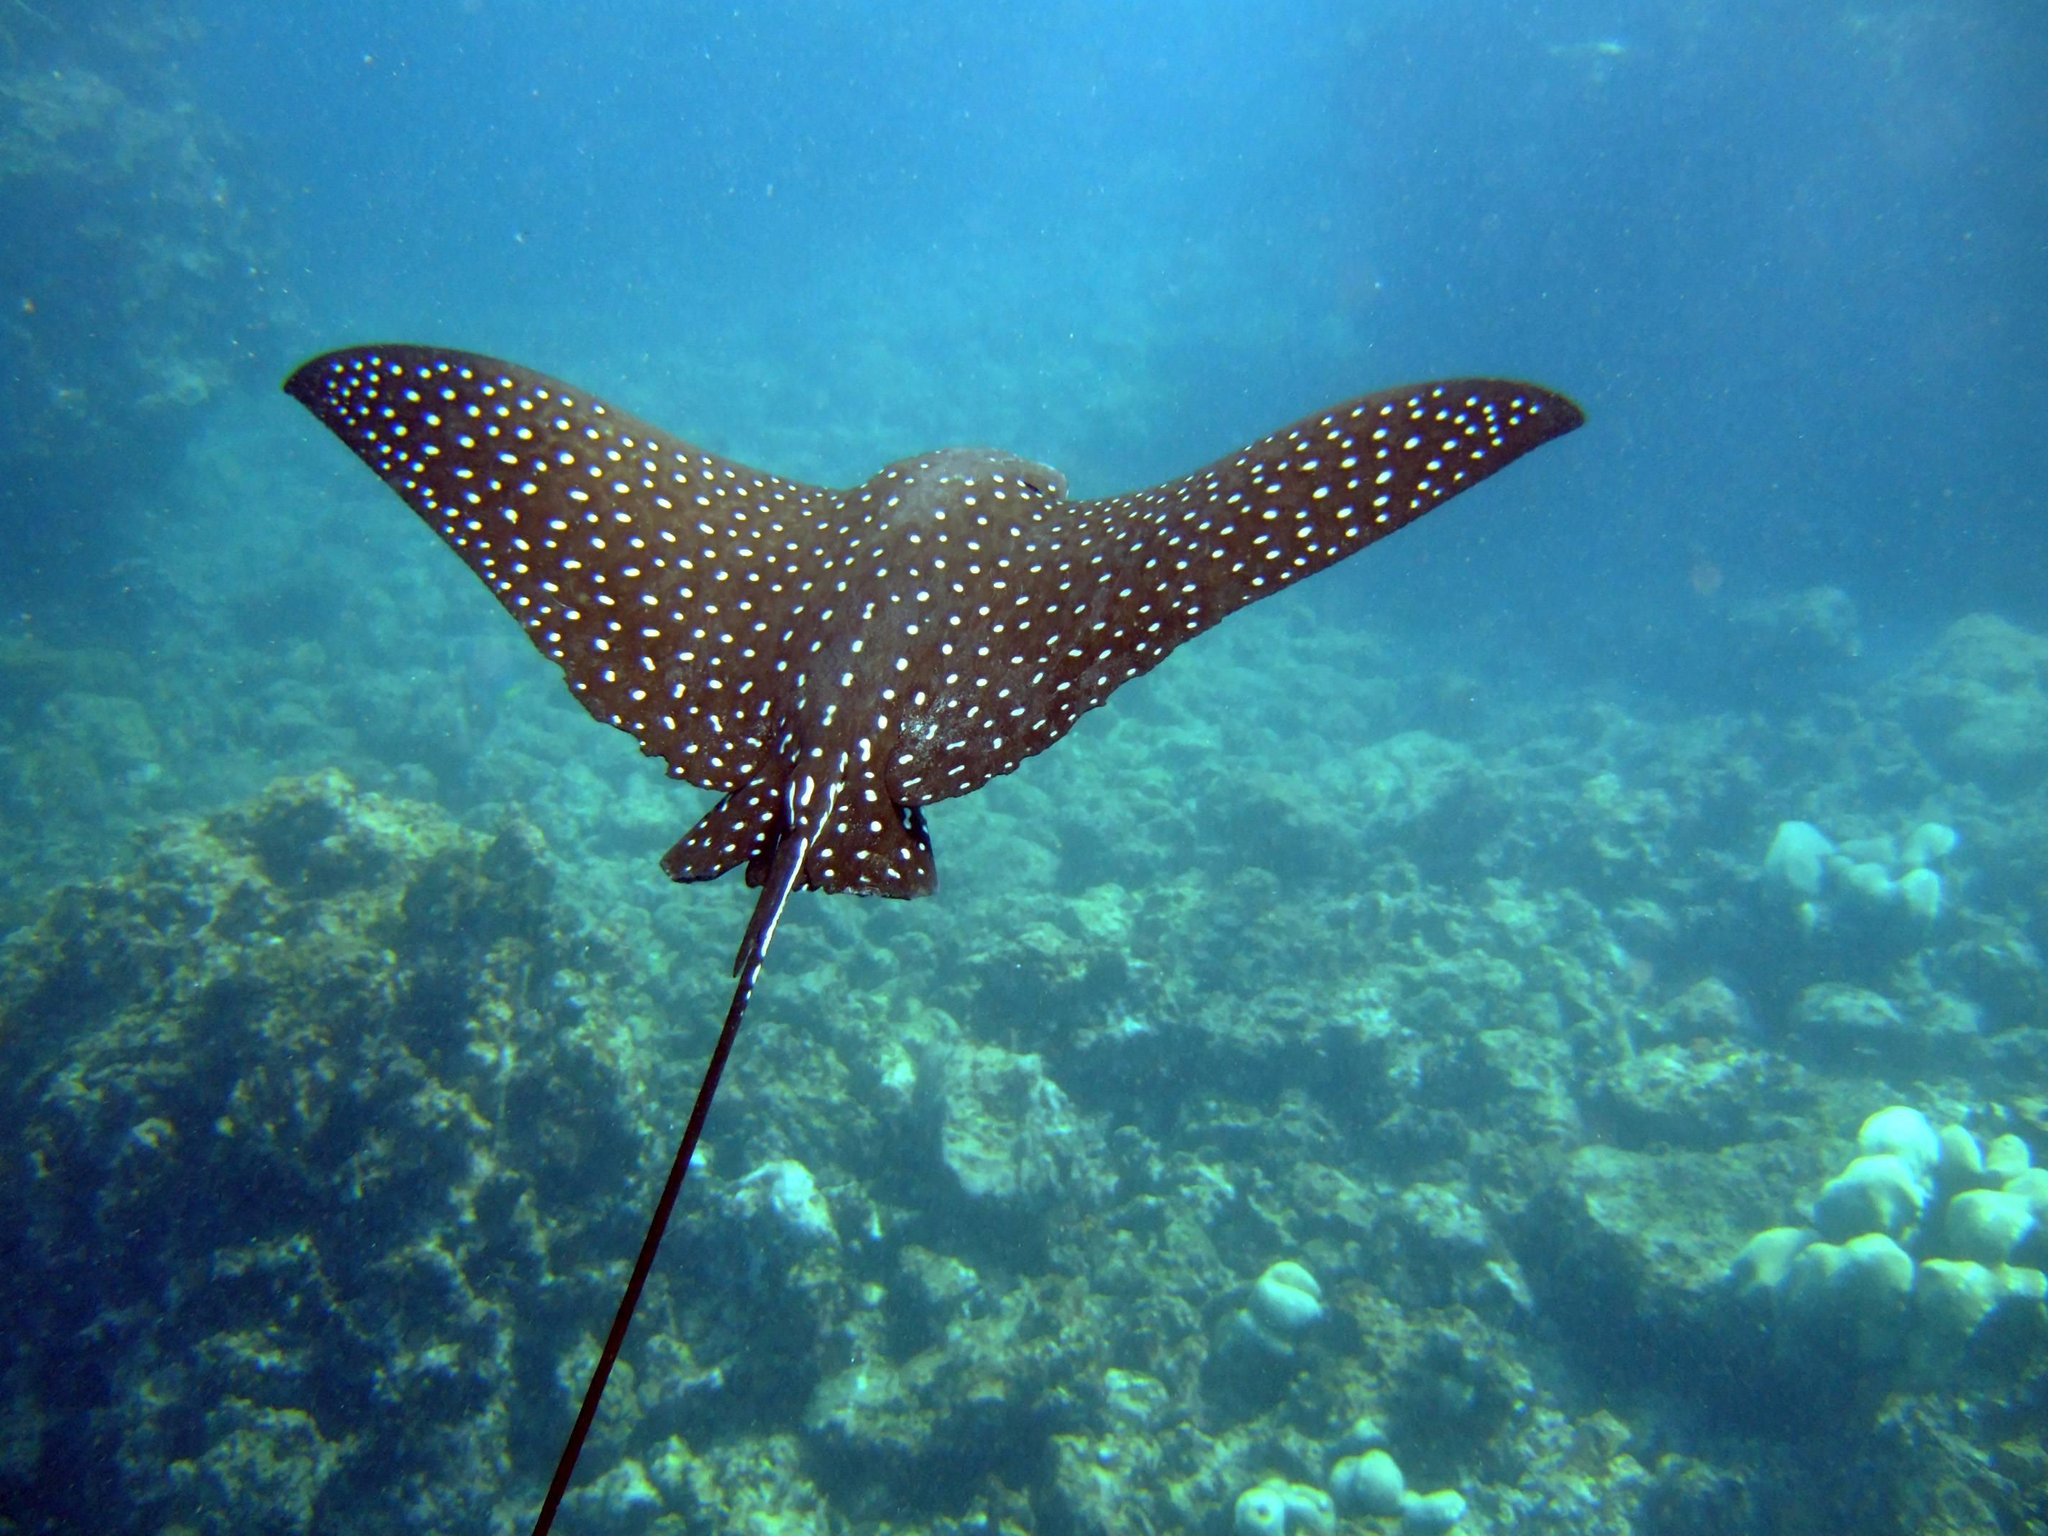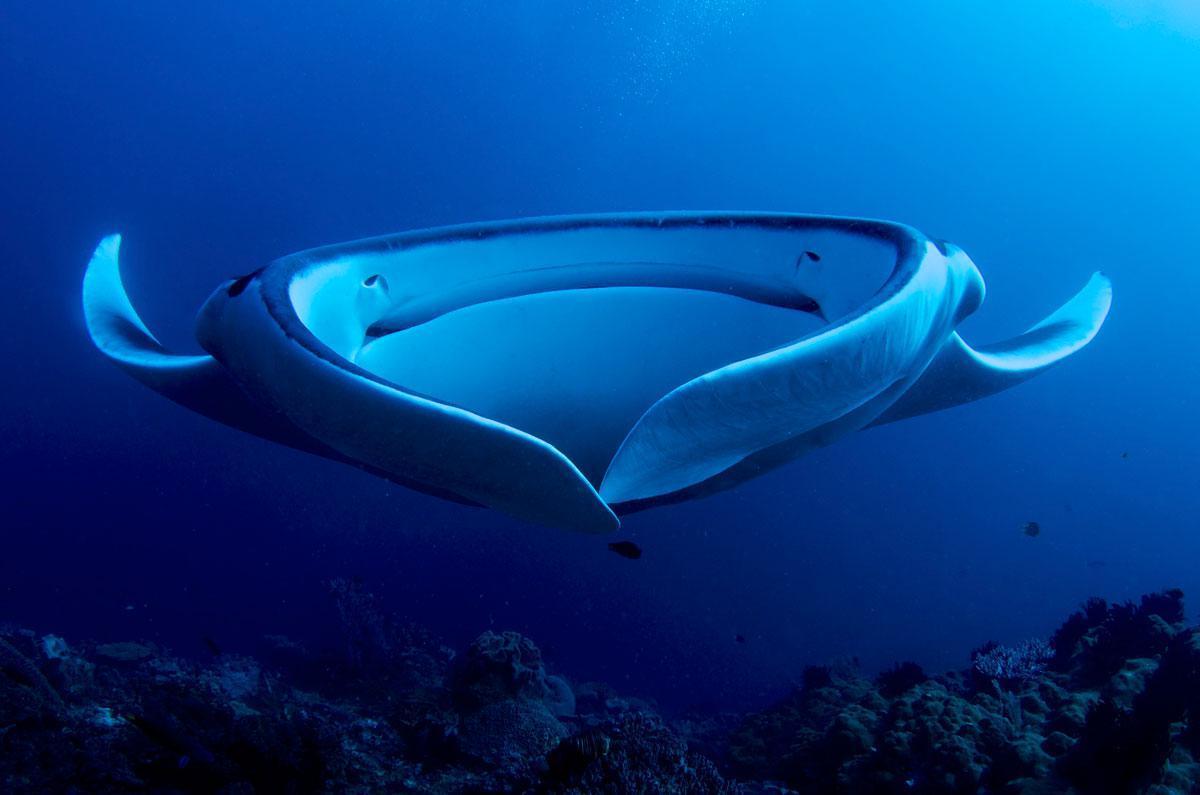The first image is the image on the left, the second image is the image on the right. Analyze the images presented: Is the assertion "There is one spotted eagle ray." valid? Answer yes or no. Yes. The first image is the image on the left, the second image is the image on the right. Analyze the images presented: Is the assertion "There is a group of stingrays in the water." valid? Answer yes or no. No. 